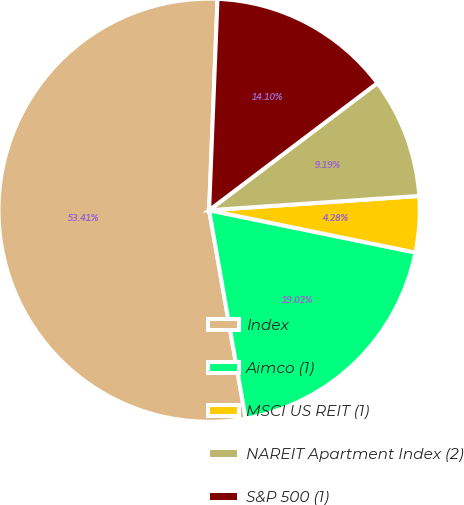<chart> <loc_0><loc_0><loc_500><loc_500><pie_chart><fcel>Index<fcel>Aimco (1)<fcel>MSCI US REIT (1)<fcel>NAREIT Apartment Index (2)<fcel>S&P 500 (1)<nl><fcel>53.41%<fcel>19.02%<fcel>4.28%<fcel>9.19%<fcel>14.1%<nl></chart> 